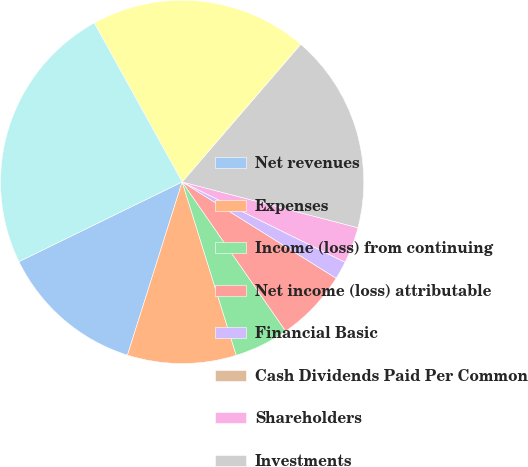Convert chart. <chart><loc_0><loc_0><loc_500><loc_500><pie_chart><fcel>Net revenues<fcel>Expenses<fcel>Income (loss) from continuing<fcel>Net income (loss) attributable<fcel>Financial Basic<fcel>Cash Dividends Paid Per Common<fcel>Shareholders<fcel>Investments<fcel>Separate account assets<fcel>Total assets<nl><fcel>12.9%<fcel>9.68%<fcel>4.84%<fcel>6.45%<fcel>1.61%<fcel>0.0%<fcel>3.23%<fcel>17.74%<fcel>19.35%<fcel>24.19%<nl></chart> 